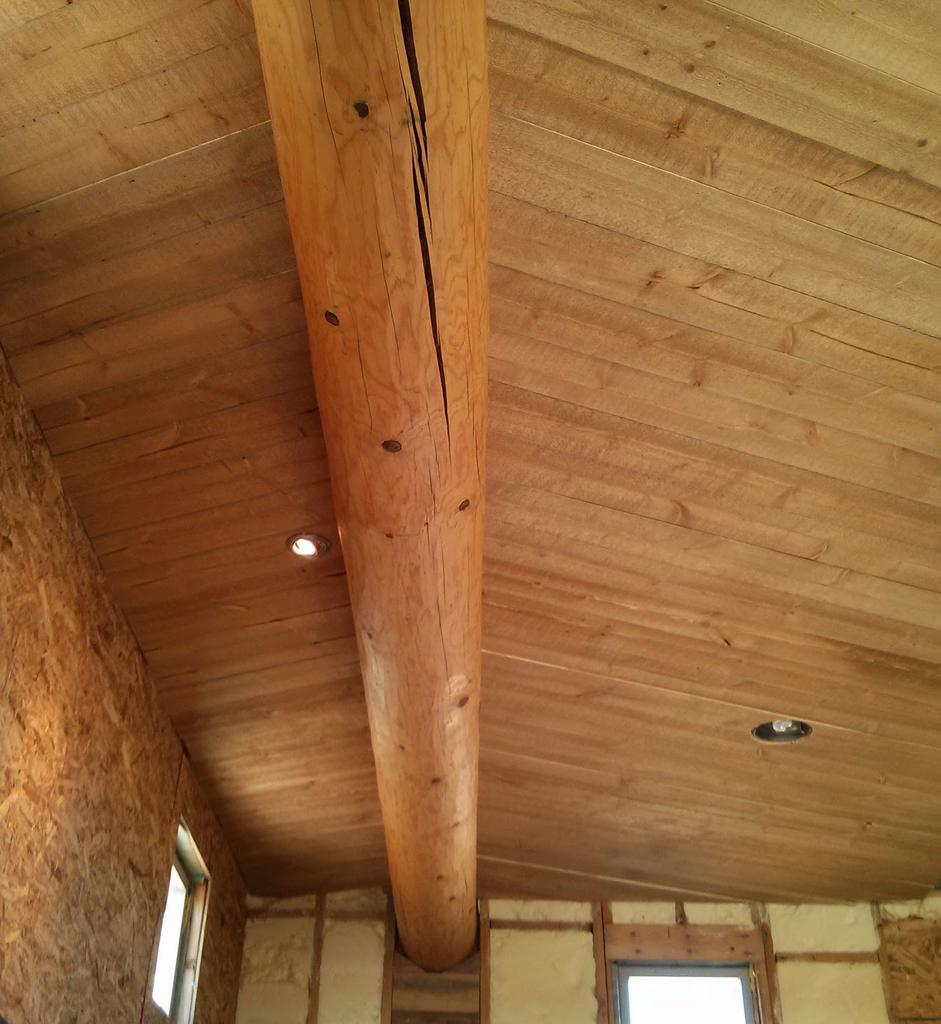What type of location is shown in the image? The image depicts the inside of a house. What feature allows natural light to enter the house? There are windows in the house. What is present on the ceiling of the house? There is a ceiling with lights in the house. How many men are visible in the image? There are no men present in the image; it depicts the inside of a house. What type of animal can be seen interacting with the place in the image? There is no animal, such as a donkey, present in the image. 